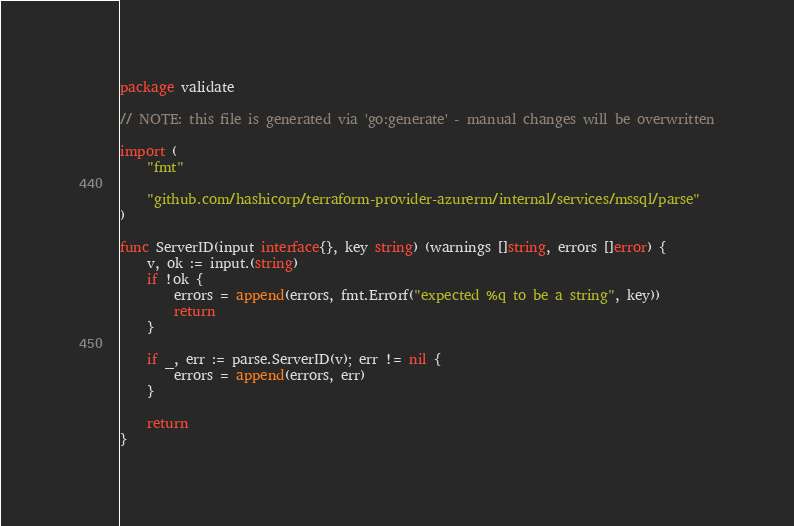Convert code to text. <code><loc_0><loc_0><loc_500><loc_500><_Go_>package validate

// NOTE: this file is generated via 'go:generate' - manual changes will be overwritten

import (
	"fmt"

	"github.com/hashicorp/terraform-provider-azurerm/internal/services/mssql/parse"
)

func ServerID(input interface{}, key string) (warnings []string, errors []error) {
	v, ok := input.(string)
	if !ok {
		errors = append(errors, fmt.Errorf("expected %q to be a string", key))
		return
	}

	if _, err := parse.ServerID(v); err != nil {
		errors = append(errors, err)
	}

	return
}
</code> 